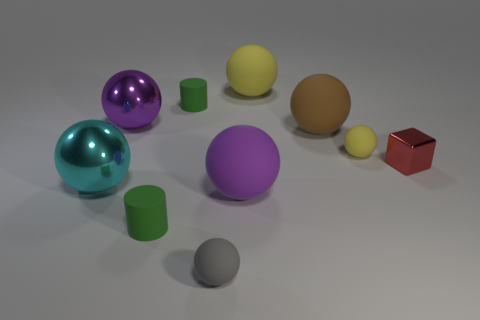Subtract all yellow spheres. How many spheres are left? 5 Subtract all gray spheres. How many spheres are left? 6 Subtract all yellow spheres. Subtract all yellow cubes. How many spheres are left? 5 Subtract all cylinders. How many objects are left? 8 Subtract 1 yellow balls. How many objects are left? 9 Subtract all tiny cyan matte cubes. Subtract all purple metal objects. How many objects are left? 9 Add 8 big purple matte objects. How many big purple matte objects are left? 9 Add 5 large blue matte objects. How many large blue matte objects exist? 5 